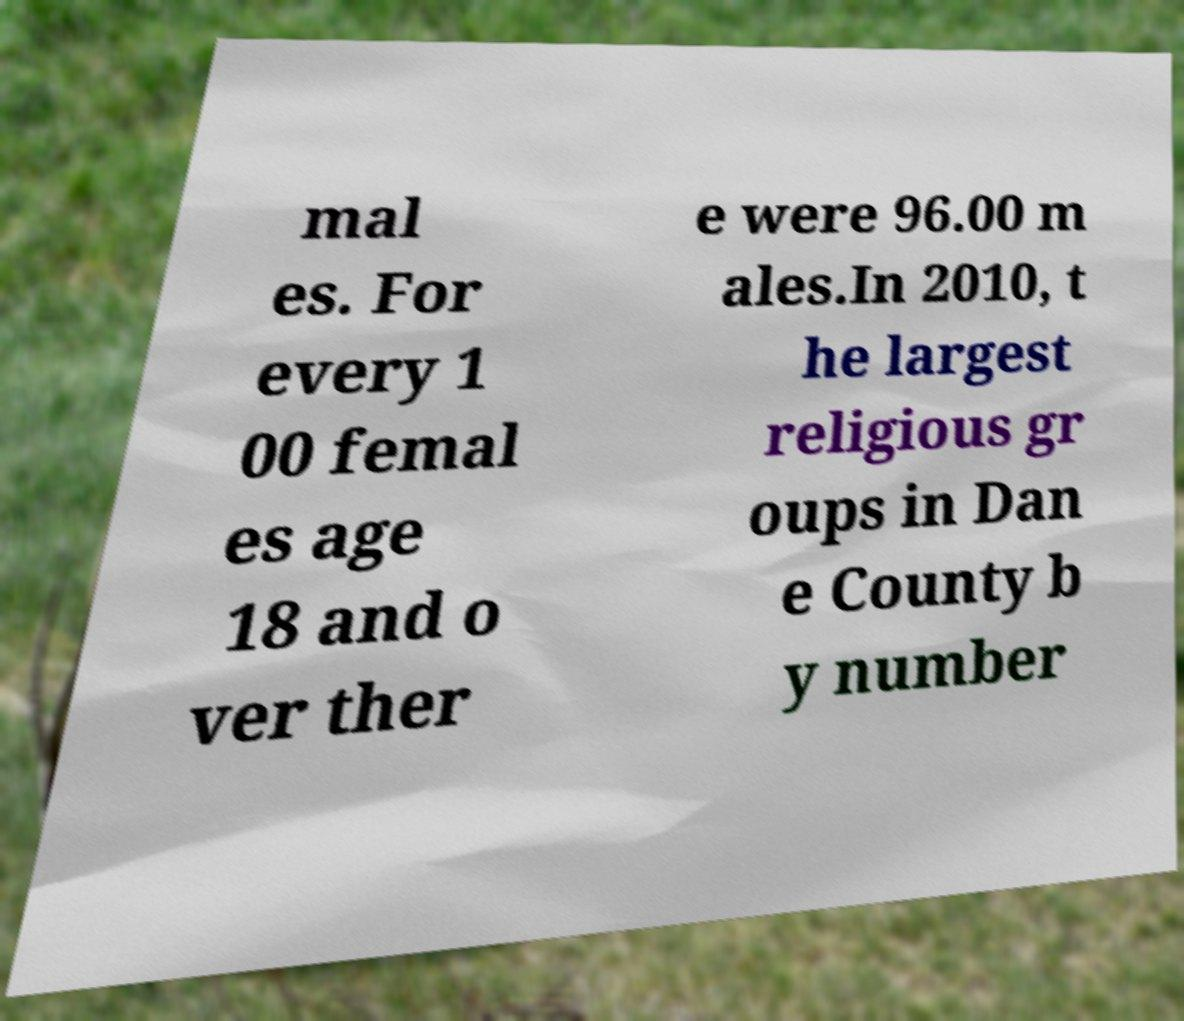What messages or text are displayed in this image? I need them in a readable, typed format. mal es. For every 1 00 femal es age 18 and o ver ther e were 96.00 m ales.In 2010, t he largest religious gr oups in Dan e County b y number 